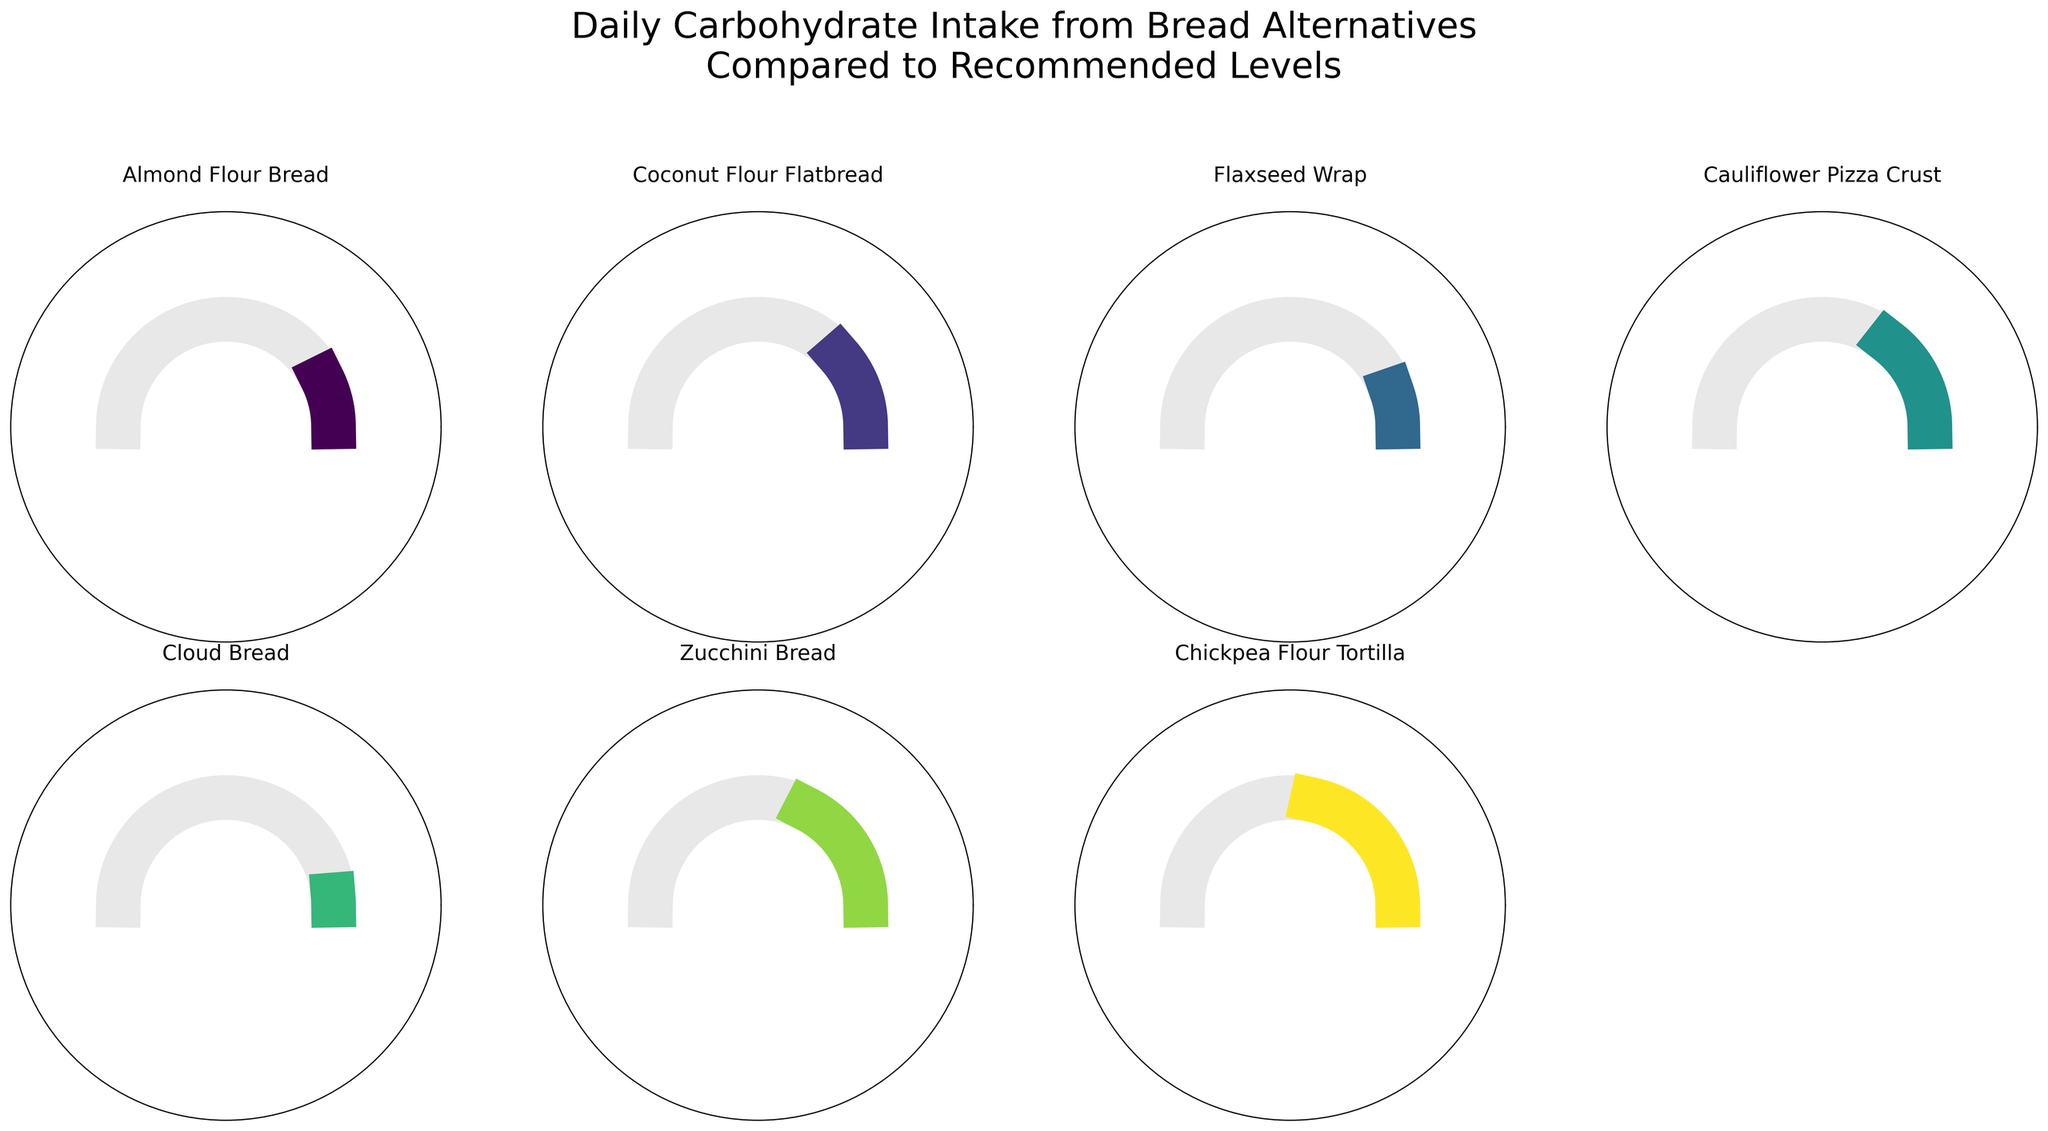what is the title of the figure? The title of the figure is usually placed at the top of the chart and summarizes the main insight the figure aims to convey. In this case, the title is "Daily Carbohydrate Intake from Bread Alternatives Compared to Recommended Levels"
Answer: Daily Carbohydrate Intake from Bread Alternatives Compared to Recommended Levels Which bread alternative has the highest percentage of daily carbohydrate intake? For each bread alternative, the percentage of daily carbohydrate intake is shown at the center of the gauge. By comparing these percentages, the bread with the highest value can be identified. Zucchini Bread, with 36%, has the highest percentage of daily carbohydrate intake.
Answer: Zucchini Bread How much lower is the carbohydrate intake of Flaxseed Wrap compared to Chickpea Flour Tortilla? To find the difference in carbohydrate intake between the two, look at their respective percentages. The Flaxseed Wrap is at 12% of the recommended daily intake; the Chickpea Flour Tortilla is at 44%. Subtract to find the difference: 44% - 12% = 32%
Answer: 32% Which bread alternative has the lowest percentage of daily carbohydrate intake? By examining the central percentages in each gauge, we can identify the lowest value. Cloud Bread, at 4%, has the lowest percentage of daily carbohydrate intake compared to the recommended levels.
Answer: Cloud Bread What are the recommended daily carb intake and the actual intake of Cauliflower Pizza Crust? The recommended daily carb intake for all bread alternatives is 50g, as shown in the data. The actual intake for the Cauliflower Pizza Crust is represented by its gauge and associated text, indicating 15g.
Answer: 50g recommended, 15g actual What is the average percentage of daily recommended intake across all bread alternatives? To find the average, sum the percentages for each bread alternative and divide by the number of alternatives. The sum is 16% (Almond Flour Bread) + 24% (Coconut Flour Flatbread) + 12% (Flaxseed Wrap) + 30% (Cauliflower Pizza Crust) + 4% (Cloud Bread) + 36% (Zucchini Bread) + 44% (Chickpea Flour Tortilla) which equals 166%. The number of alternatives is 7. So, 166% / 7 ≈ 23.7%
Answer: 23.7% Which bread alternatives exceed 30% of the recommended daily carbohydrate intake? By scanning the percentages at the center of the gauges, locate those over 30%. Cauliflower Pizza Crust (30%), Zucchini Bread (36%), and Chickpea Flour Tortilla (44%) exceed 30% of the recommended daily carbohydrate intake.
Answer: Cauliflower Pizza Crust, Zucchini Bread, Chickpea Flour Tortilla Compare the carbohydrate intake of Almond Flour Bread and Coconut Flour Flatbread. Which one is higher and by how much? Almond Flour Bread has 8g of carbs, translating to 16% of the recommended intake, while Coconut Flour Flatbread has 12g, translating to 24%. The difference in percentage is 24% - 16% = 8%.
Answer: Coconut Flour Flatbread, 8% higher How many bread alternatives have a daily carbohydrate intake below 20% of the recommended value? Identify the gauges with a percentage below 20%. This includes Almond Flour Bread (16%), Flaxseed Wrap (12%), and Cloud Bread (4%). Thus, there are 3 bread alternatives with daily carbohydrate intakes below 20%.
Answer: 3 